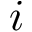Convert formula to latex. <formula><loc_0><loc_0><loc_500><loc_500>i</formula> 